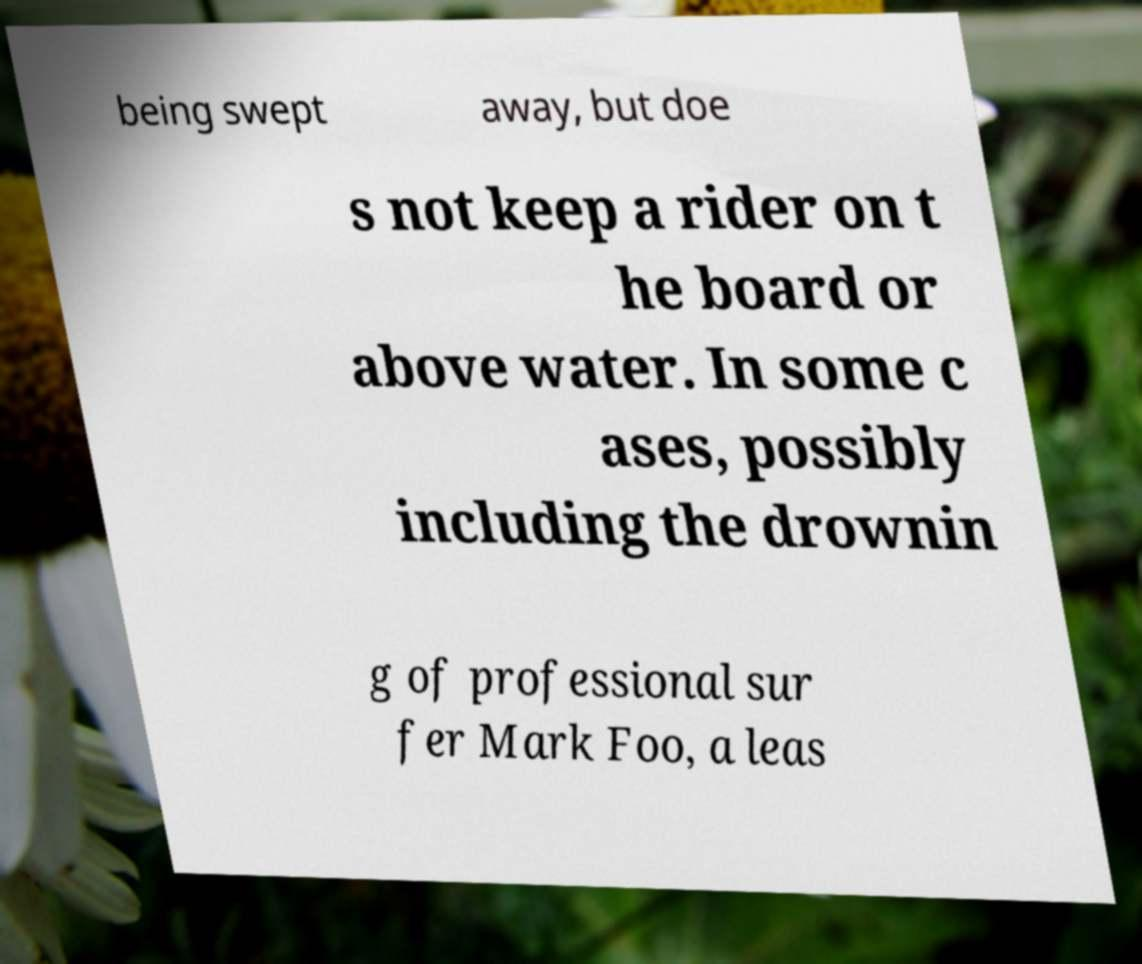For documentation purposes, I need the text within this image transcribed. Could you provide that? being swept away, but doe s not keep a rider on t he board or above water. In some c ases, possibly including the drownin g of professional sur fer Mark Foo, a leas 